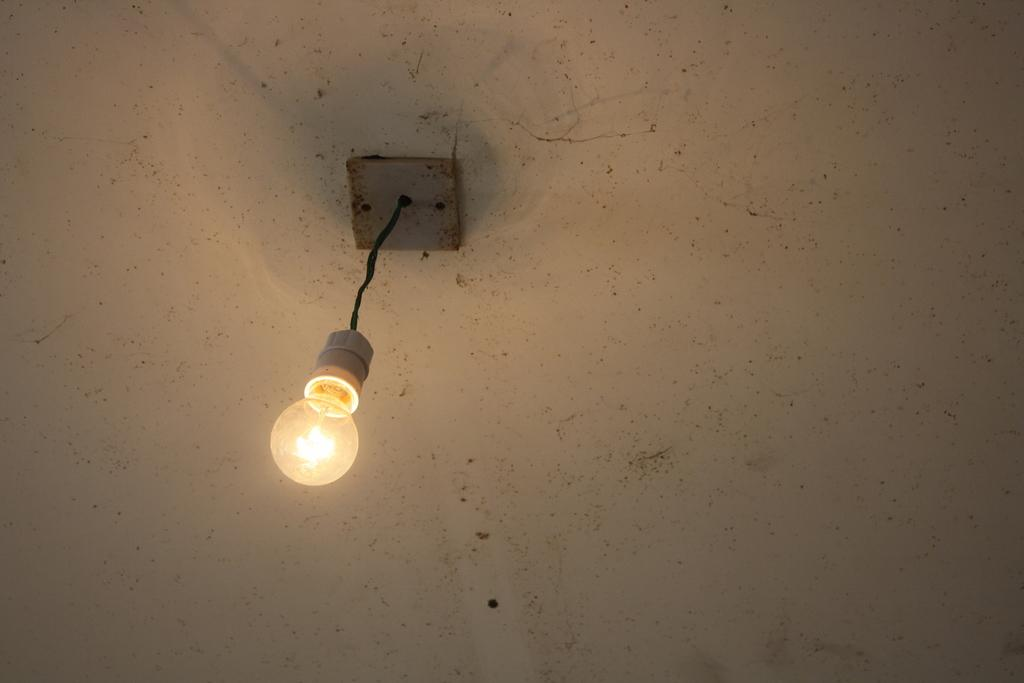What object is present in the image? There is a bulb in the image. How is the bulb connected or attached in the image? The bulb is fixed through a wire. How many snails are crawling on the bulb in the image? There are no snails present in the image; it only features a bulb and a wire. Can you see any dinosaurs in the image? There are no dinosaurs present in the image; it only features a bulb and a wire. 